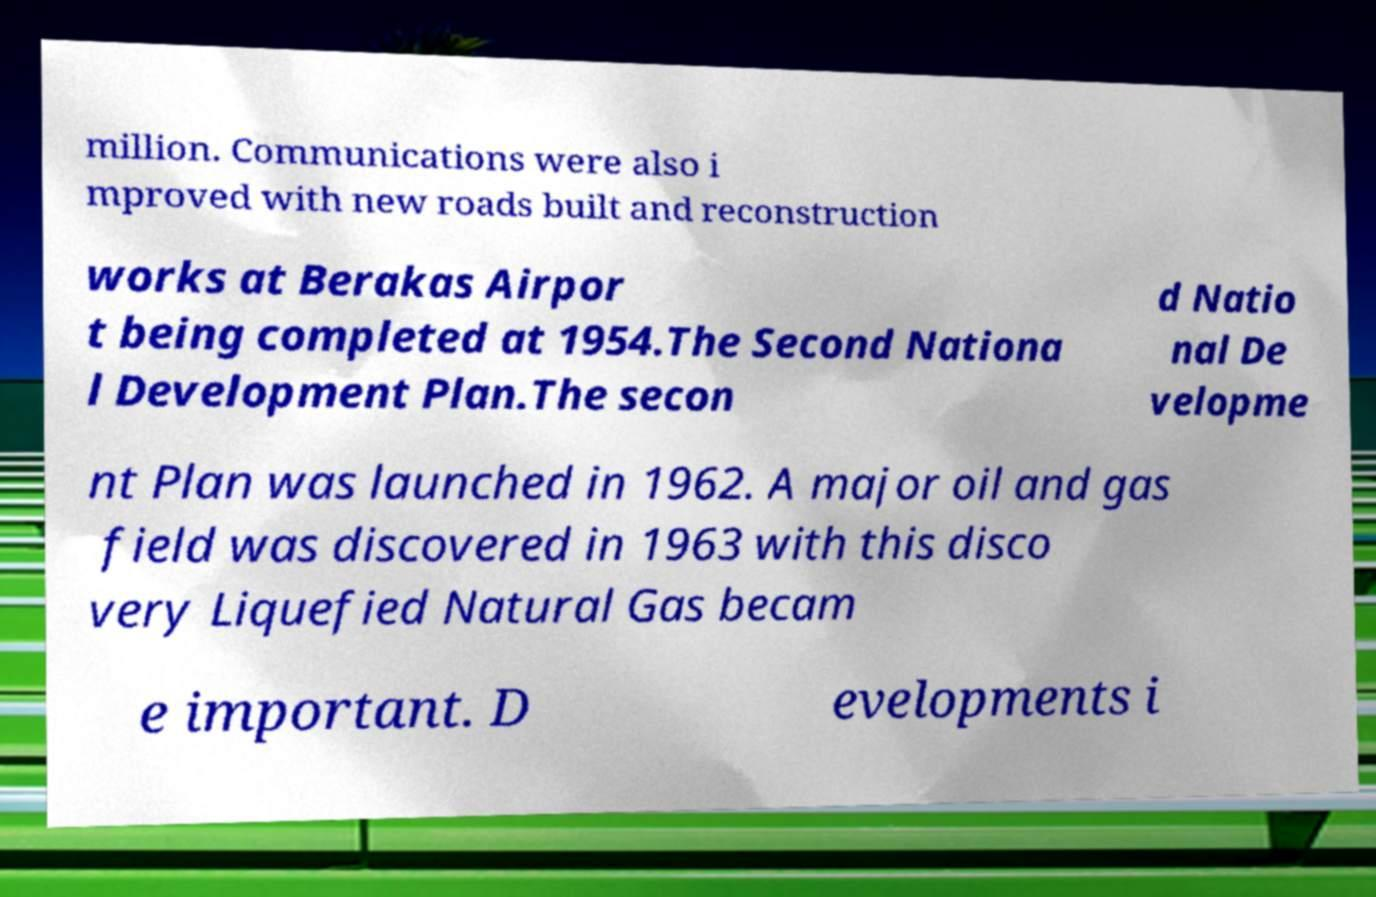Can you read and provide the text displayed in the image?This photo seems to have some interesting text. Can you extract and type it out for me? million. Communications were also i mproved with new roads built and reconstruction works at Berakas Airpor t being completed at 1954.The Second Nationa l Development Plan.The secon d Natio nal De velopme nt Plan was launched in 1962. A major oil and gas field was discovered in 1963 with this disco very Liquefied Natural Gas becam e important. D evelopments i 